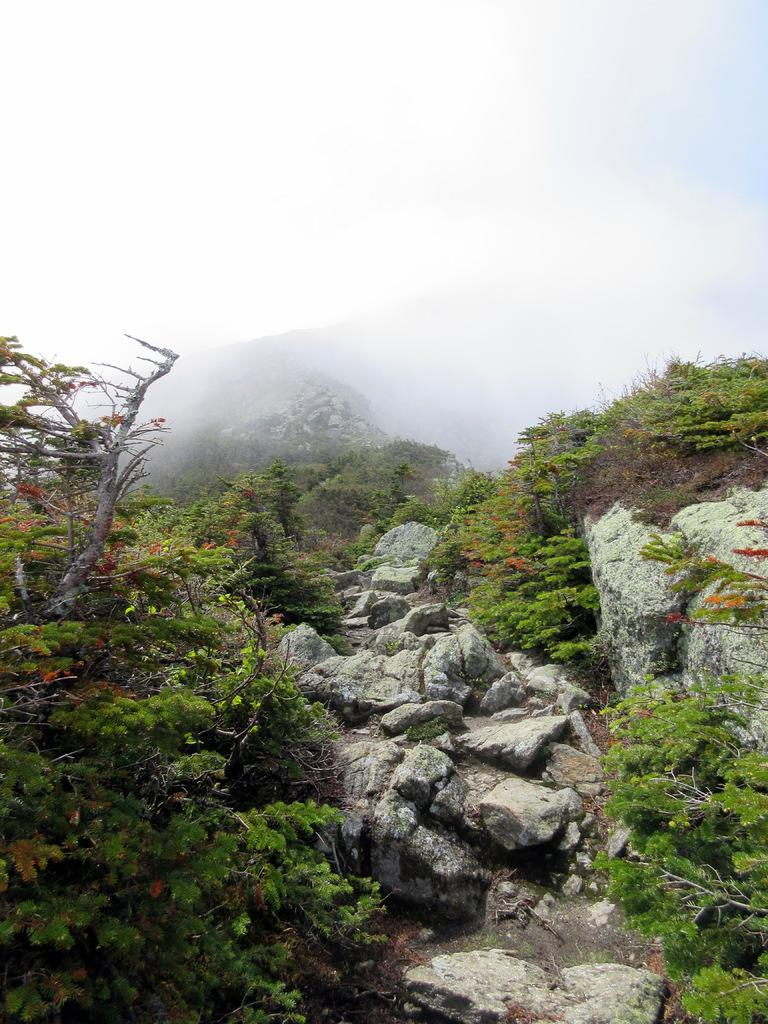What type of vegetation can be seen in the image? There is a tree and plants in the image. Where are the tree and plants located? The tree and plants are on mountains. What is the weather condition in the image? There appears to be fog at the top of the image. What type of tramp can be seen jumping over the tree in the image? There is no tramp present in the image; it features a tree and plants on mountains with fog at the top. What part of the tree is made of flesh in the image? There is no part of the tree made of flesh in the image; the tree is a natural plant with bark and foliage. 